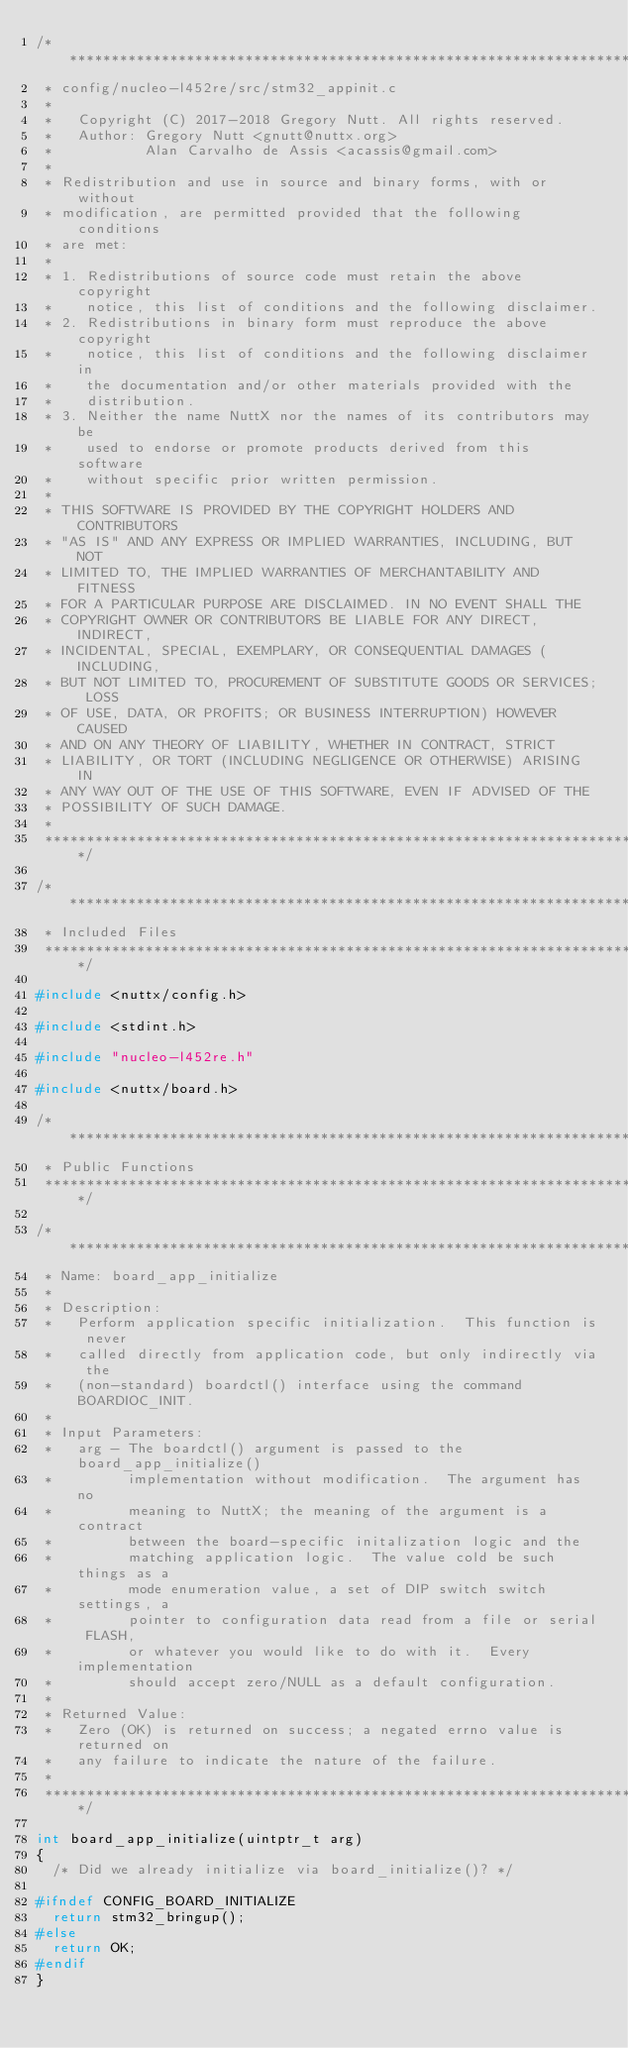<code> <loc_0><loc_0><loc_500><loc_500><_C_>/****************************************************************************
 * config/nucleo-l452re/src/stm32_appinit.c
 *
 *   Copyright (C) 2017-2018 Gregory Nutt. All rights reserved.
 *   Author: Gregory Nutt <gnutt@nuttx.org>
 *           Alan Carvalho de Assis <acassis@gmail.com>
 *
 * Redistribution and use in source and binary forms, with or without
 * modification, are permitted provided that the following conditions
 * are met:
 *
 * 1. Redistributions of source code must retain the above copyright
 *    notice, this list of conditions and the following disclaimer.
 * 2. Redistributions in binary form must reproduce the above copyright
 *    notice, this list of conditions and the following disclaimer in
 *    the documentation and/or other materials provided with the
 *    distribution.
 * 3. Neither the name NuttX nor the names of its contributors may be
 *    used to endorse or promote products derived from this software
 *    without specific prior written permission.
 *
 * THIS SOFTWARE IS PROVIDED BY THE COPYRIGHT HOLDERS AND CONTRIBUTORS
 * "AS IS" AND ANY EXPRESS OR IMPLIED WARRANTIES, INCLUDING, BUT NOT
 * LIMITED TO, THE IMPLIED WARRANTIES OF MERCHANTABILITY AND FITNESS
 * FOR A PARTICULAR PURPOSE ARE DISCLAIMED. IN NO EVENT SHALL THE
 * COPYRIGHT OWNER OR CONTRIBUTORS BE LIABLE FOR ANY DIRECT, INDIRECT,
 * INCIDENTAL, SPECIAL, EXEMPLARY, OR CONSEQUENTIAL DAMAGES (INCLUDING,
 * BUT NOT LIMITED TO, PROCUREMENT OF SUBSTITUTE GOODS OR SERVICES; LOSS
 * OF USE, DATA, OR PROFITS; OR BUSINESS INTERRUPTION) HOWEVER CAUSED
 * AND ON ANY THEORY OF LIABILITY, WHETHER IN CONTRACT, STRICT
 * LIABILITY, OR TORT (INCLUDING NEGLIGENCE OR OTHERWISE) ARISING IN
 * ANY WAY OUT OF THE USE OF THIS SOFTWARE, EVEN IF ADVISED OF THE
 * POSSIBILITY OF SUCH DAMAGE.
 *
 ****************************************************************************/

/****************************************************************************
 * Included Files
 ****************************************************************************/

#include <nuttx/config.h>

#include <stdint.h>

#include "nucleo-l452re.h"

#include <nuttx/board.h>

/****************************************************************************
 * Public Functions
 ****************************************************************************/

/****************************************************************************
 * Name: board_app_initialize
 *
 * Description:
 *   Perform application specific initialization.  This function is never
 *   called directly from application code, but only indirectly via the
 *   (non-standard) boardctl() interface using the command BOARDIOC_INIT.
 *
 * Input Parameters:
 *   arg - The boardctl() argument is passed to the board_app_initialize()
 *         implementation without modification.  The argument has no
 *         meaning to NuttX; the meaning of the argument is a contract
 *         between the board-specific initalization logic and the
 *         matching application logic.  The value cold be such things as a
 *         mode enumeration value, a set of DIP switch switch settings, a
 *         pointer to configuration data read from a file or serial FLASH,
 *         or whatever you would like to do with it.  Every implementation
 *         should accept zero/NULL as a default configuration.
 *
 * Returned Value:
 *   Zero (OK) is returned on success; a negated errno value is returned on
 *   any failure to indicate the nature of the failure.
 *
 ****************************************************************************/

int board_app_initialize(uintptr_t arg)
{
  /* Did we already initialize via board_initialize()? */

#ifndef CONFIG_BOARD_INITIALIZE
  return stm32_bringup();
#else
  return OK;
#endif
}
</code> 